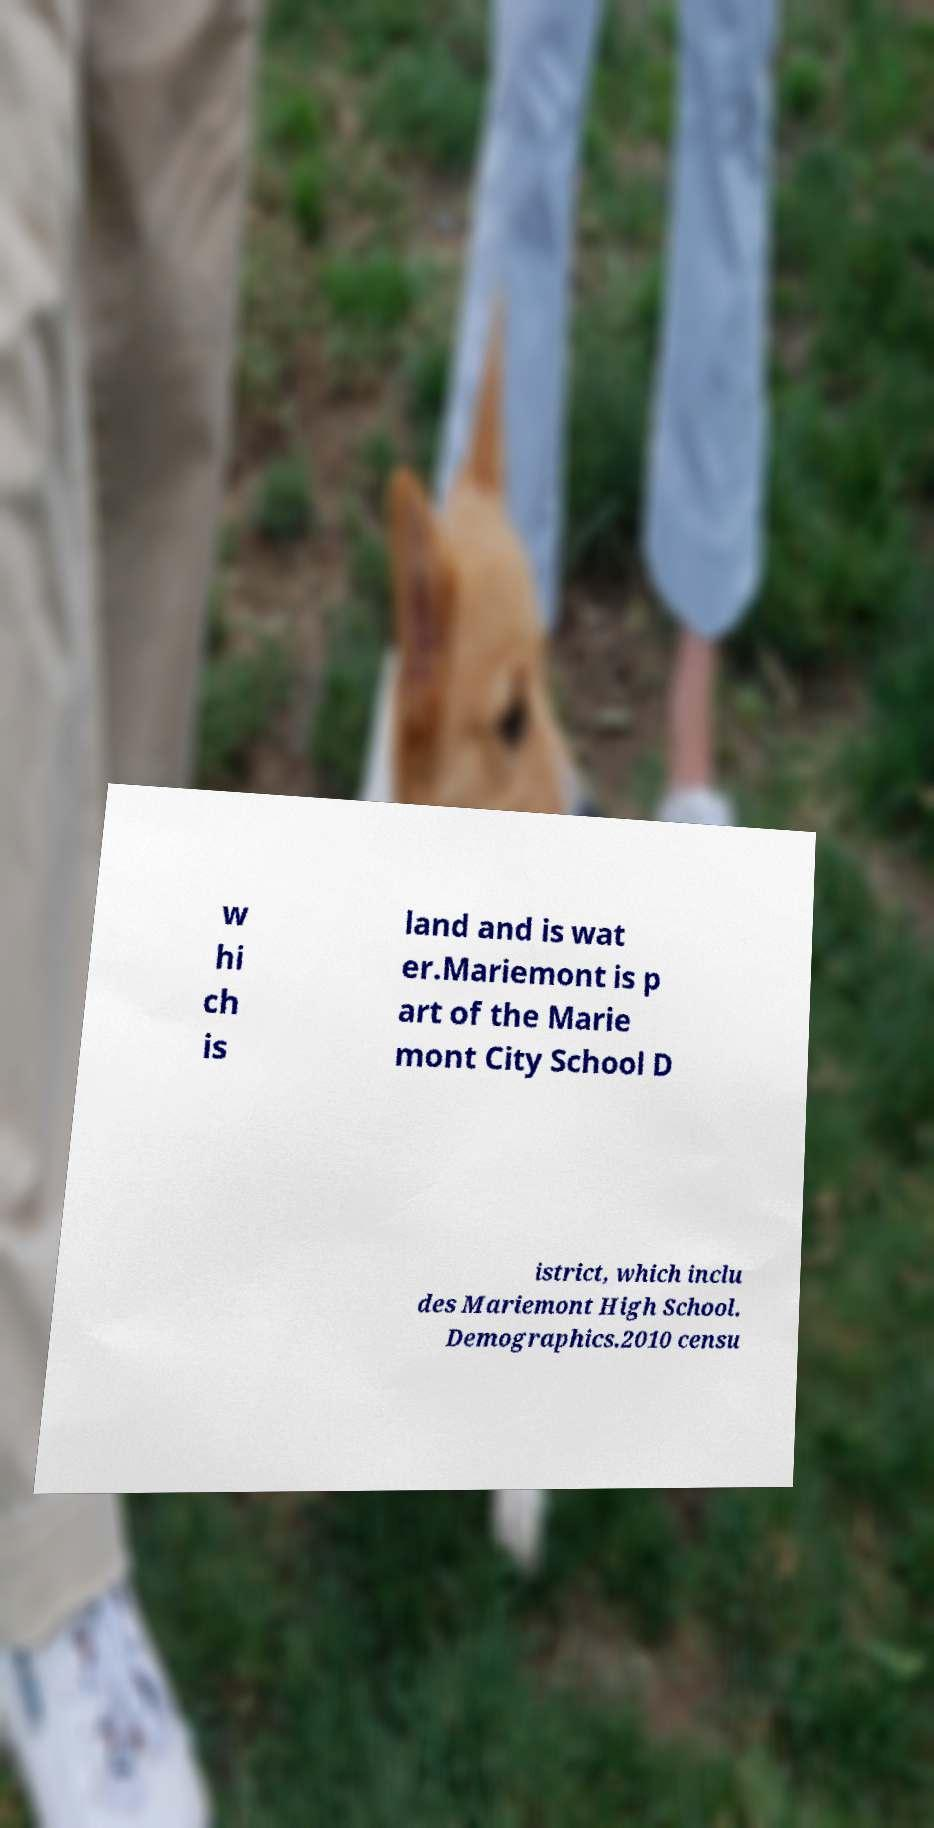I need the written content from this picture converted into text. Can you do that? w hi ch is land and is wat er.Mariemont is p art of the Marie mont City School D istrict, which inclu des Mariemont High School. Demographics.2010 censu 